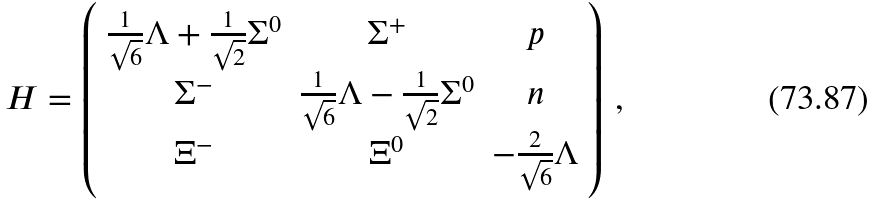Convert formula to latex. <formula><loc_0><loc_0><loc_500><loc_500>H = \left ( \begin{array} { c c c } \frac { 1 } { \sqrt { 6 } } \Lambda + \frac { 1 } { \sqrt { 2 } } \Sigma ^ { 0 } & \Sigma ^ { + } & p \\ \Sigma ^ { - } & \frac { 1 } { \sqrt { 6 } } \Lambda - \frac { 1 } { \sqrt { 2 } } \Sigma ^ { 0 } & n \\ \Xi ^ { - } & \Xi ^ { 0 } & - \frac { 2 } { \sqrt { 6 } } \Lambda \end{array} \right ) \, ,</formula> 